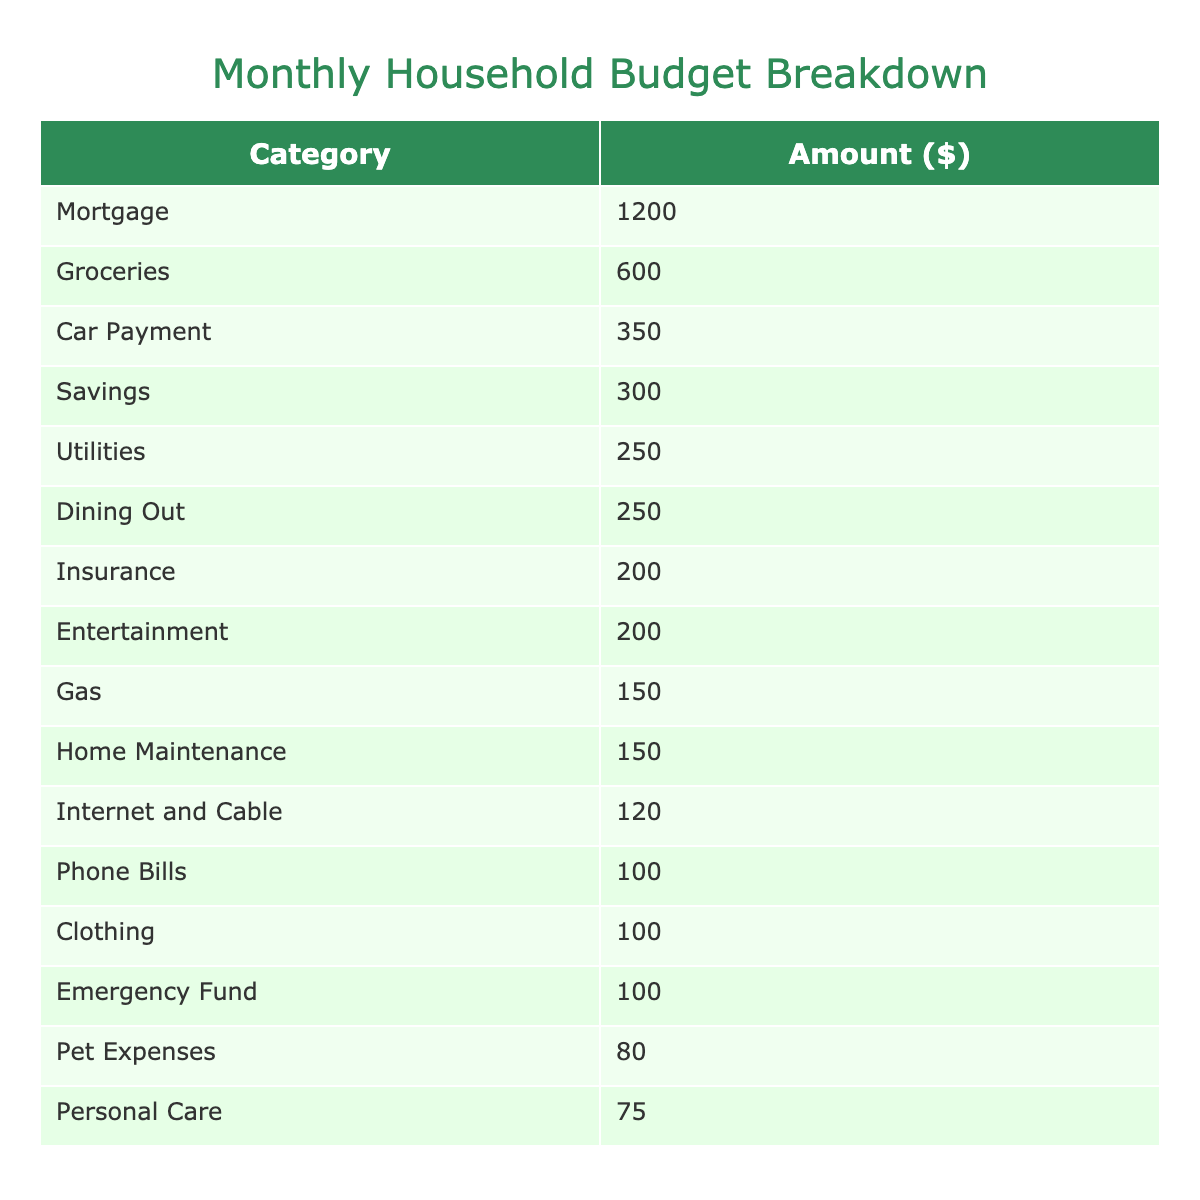What is the total amount spent on Groceries and Dining Out? The amount spent on Groceries is 600, and Dining Out is 250. Adding these two amounts gives: 600 + 250 = 850.
Answer: 850 Which category has the highest expense? By examining the table, Mortgage has the highest expense at 1200.
Answer: 1200 What is the total amount spent on Utilities and Phone Bills? Utilities cost 250 and Phone Bills cost 100. Adding these amounts gives: 250 + 100 = 350.
Answer: 350 Is the Emergency Fund amount greater than the Pet Expenses? The Emergency Fund is 100 and Pet Expenses is 80. Since 100 is greater than 80, the answer is yes.
Answer: Yes How much do you spend on Insurance compared to Car Payment? Insurance is 200 and Car Payment is 350. Since 200 is less than 350, the comparison shows that Insurance is lower.
Answer: Insurance is lower What is the total monthly budget for savings categories (Savings and Emergency Fund)? The Savings amount is 300 and the Emergency Fund is 100. The sum is: 300 + 100 = 400.
Answer: 400 Is the combined total of Clothing and Personal Care expenses more than 200? Clothing is 100 and Personal Care is 75. Their total is 100 + 75 = 175, which is less than 200.
Answer: No If you were to cut the Entertainment budget by half, what would be the new amount? The original Entertainment budget is 200. Half of this is 200 / 2 = 100. Thus, the new amount would be 100.
Answer: 100 What percentage of the total budget is spent on Mortgage? First, calculate the total expenses: sum all amounts which equals 3950. The Mortgage expense is 1200. The percentage is (1200 / 3950) * 100 ≈ 30.38%.
Answer: 30.38% What is the average spending across all categories? Sum all the category amounts, which equals 3950, and divide by the number of categories (15): 3950 / 15 ≈ 263.33.
Answer: 263.33 